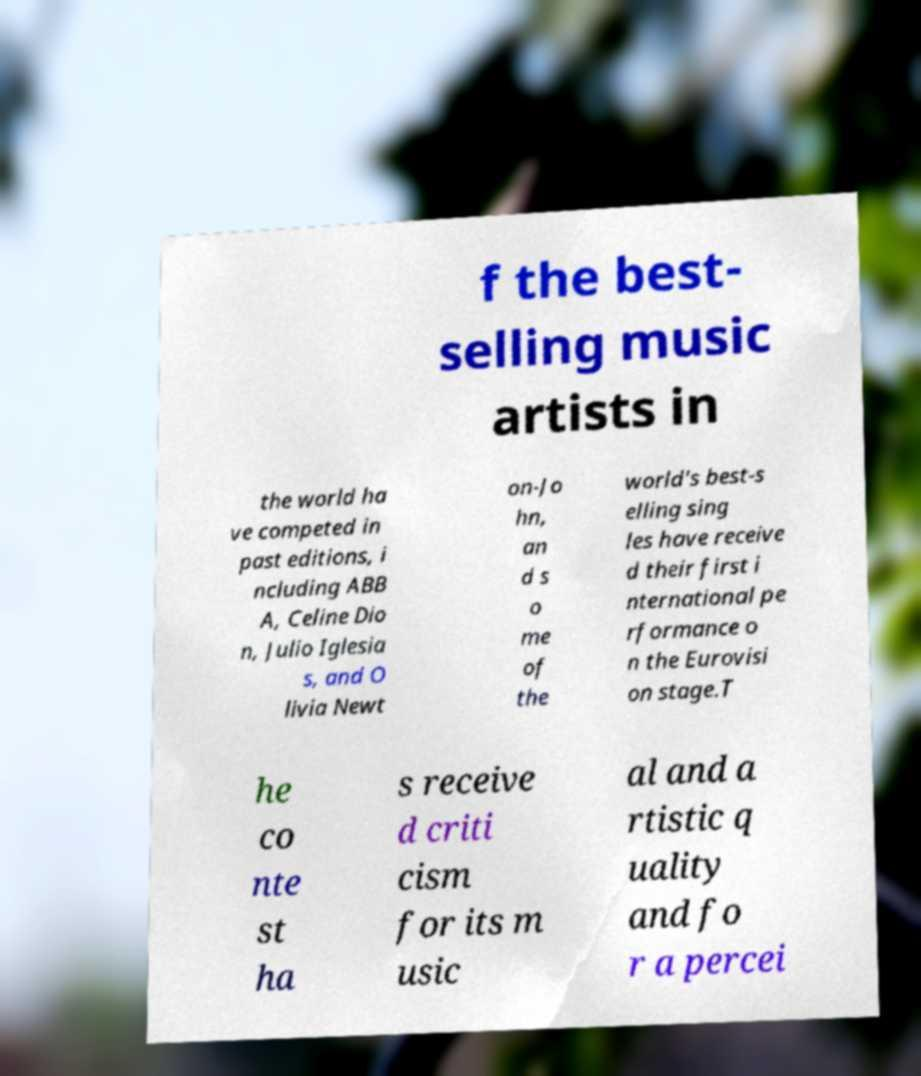Please read and relay the text visible in this image. What does it say? f the best- selling music artists in the world ha ve competed in past editions, i ncluding ABB A, Celine Dio n, Julio Iglesia s, and O livia Newt on-Jo hn, an d s o me of the world's best-s elling sing les have receive d their first i nternational pe rformance o n the Eurovisi on stage.T he co nte st ha s receive d criti cism for its m usic al and a rtistic q uality and fo r a percei 